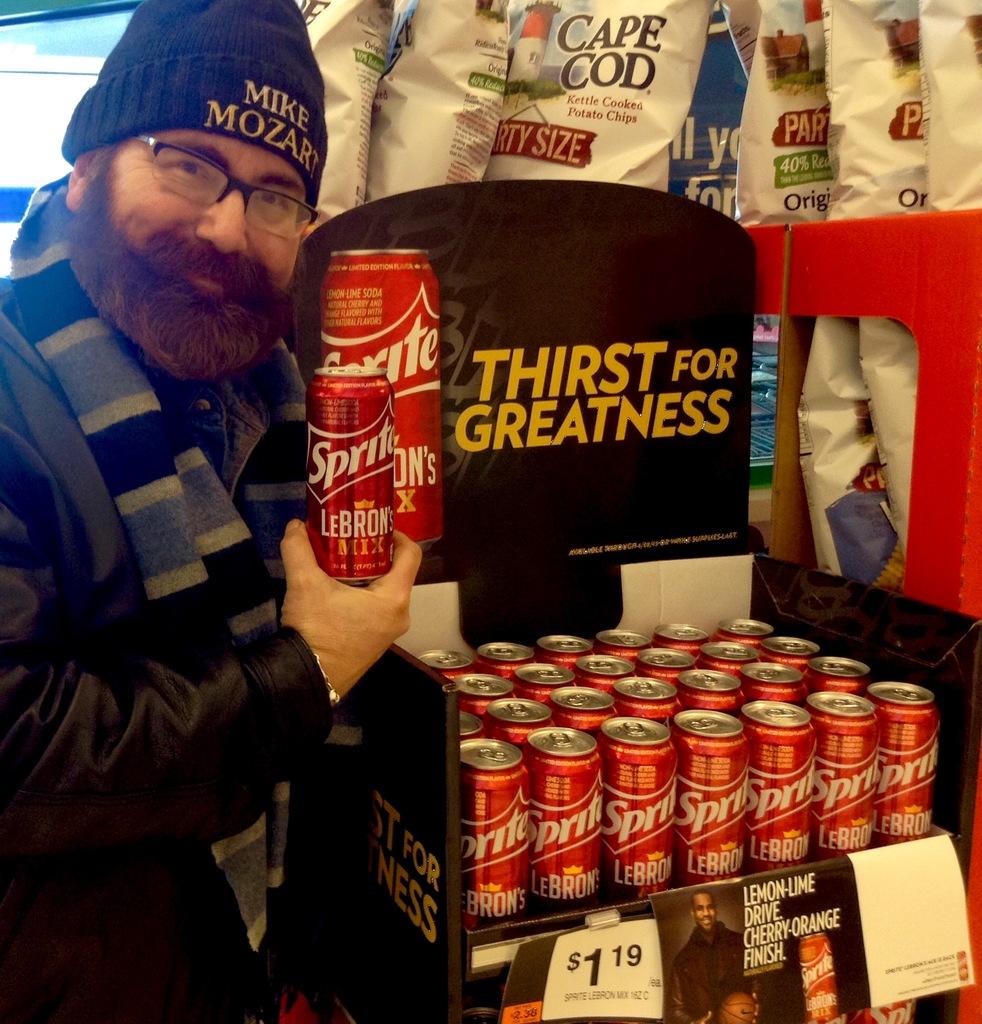What is the brand of the can?
Ensure brevity in your answer.  Sprite. 